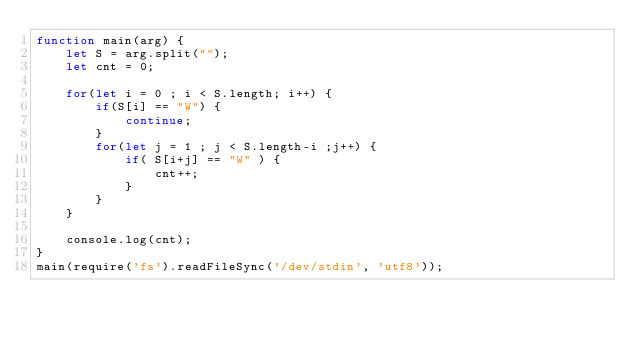Convert code to text. <code><loc_0><loc_0><loc_500><loc_500><_JavaScript_>function main(arg) {
    let S = arg.split("");
    let cnt = 0;
    
    for(let i = 0 ; i < S.length; i++) {
        if(S[i] == "W") {
            continue;
        }
        for(let j = 1 ; j < S.length-i ;j++) {
            if( S[i+j] == "W" ) {
                cnt++;
            }   
        }
    }
    
    console.log(cnt);
}
main(require('fs').readFileSync('/dev/stdin', 'utf8'));</code> 